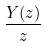Convert formula to latex. <formula><loc_0><loc_0><loc_500><loc_500>\frac { Y ( z ) } { z }</formula> 